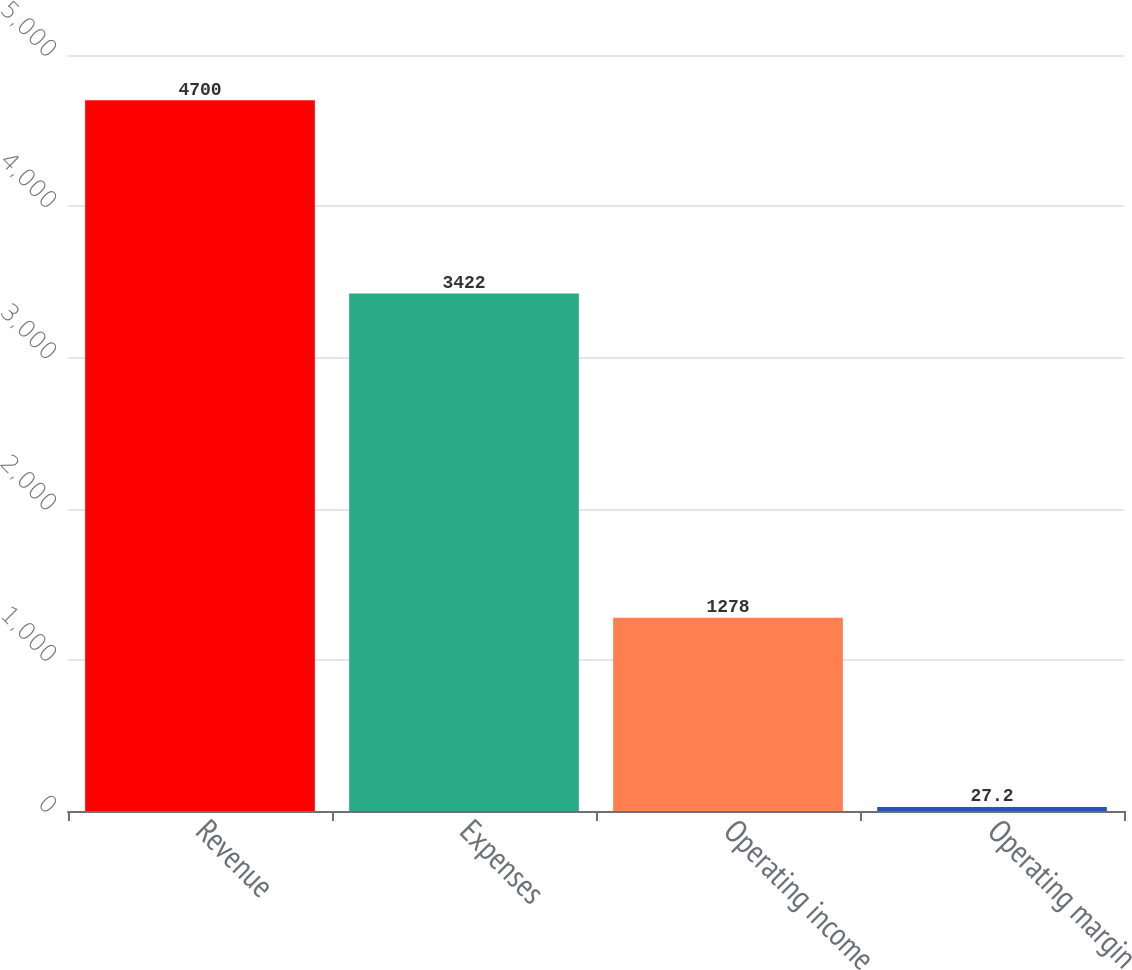<chart> <loc_0><loc_0><loc_500><loc_500><bar_chart><fcel>Revenue<fcel>Expenses<fcel>Operating income<fcel>Operating margin<nl><fcel>4700<fcel>3422<fcel>1278<fcel>27.2<nl></chart> 